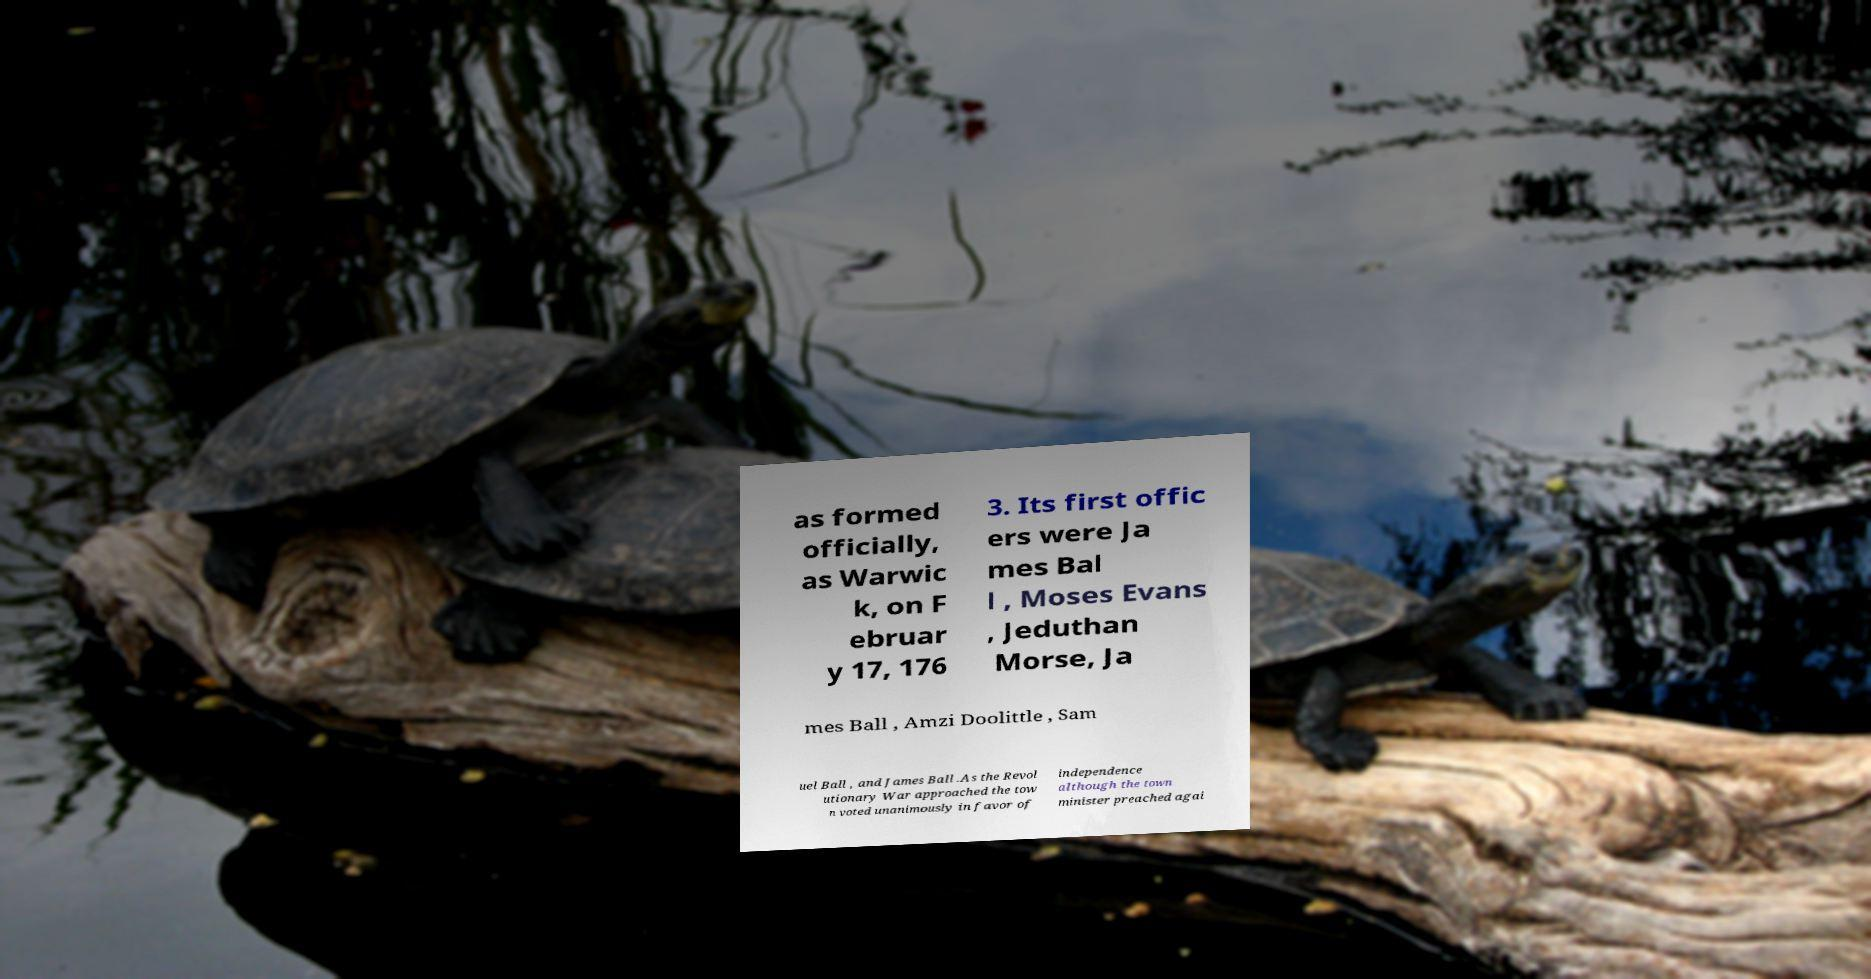I need the written content from this picture converted into text. Can you do that? as formed officially, as Warwic k, on F ebruar y 17, 176 3. Its first offic ers were Ja mes Bal l , Moses Evans , Jeduthan Morse, Ja mes Ball , Amzi Doolittle , Sam uel Ball , and James Ball .As the Revol utionary War approached the tow n voted unanimously in favor of independence although the town minister preached agai 